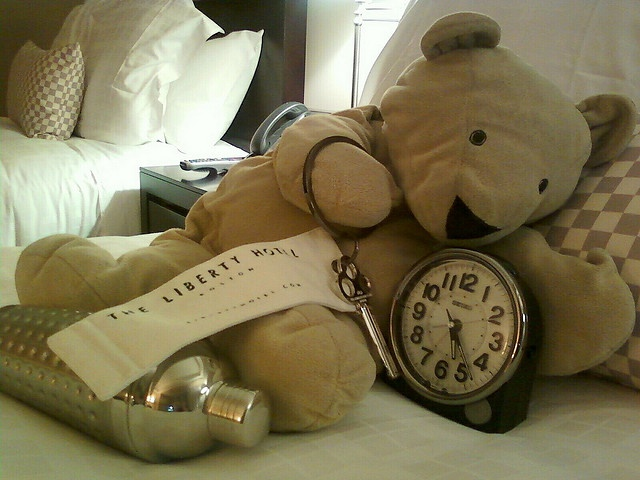Describe the objects in this image and their specific colors. I can see teddy bear in darkgreen, olive, tan, and black tones, bed in darkgreen, beige, gray, and tan tones, bed in darkgreen, gray, olive, and black tones, bed in darkgreen, gray, olive, and black tones, and clock in darkgreen, black, and olive tones in this image. 